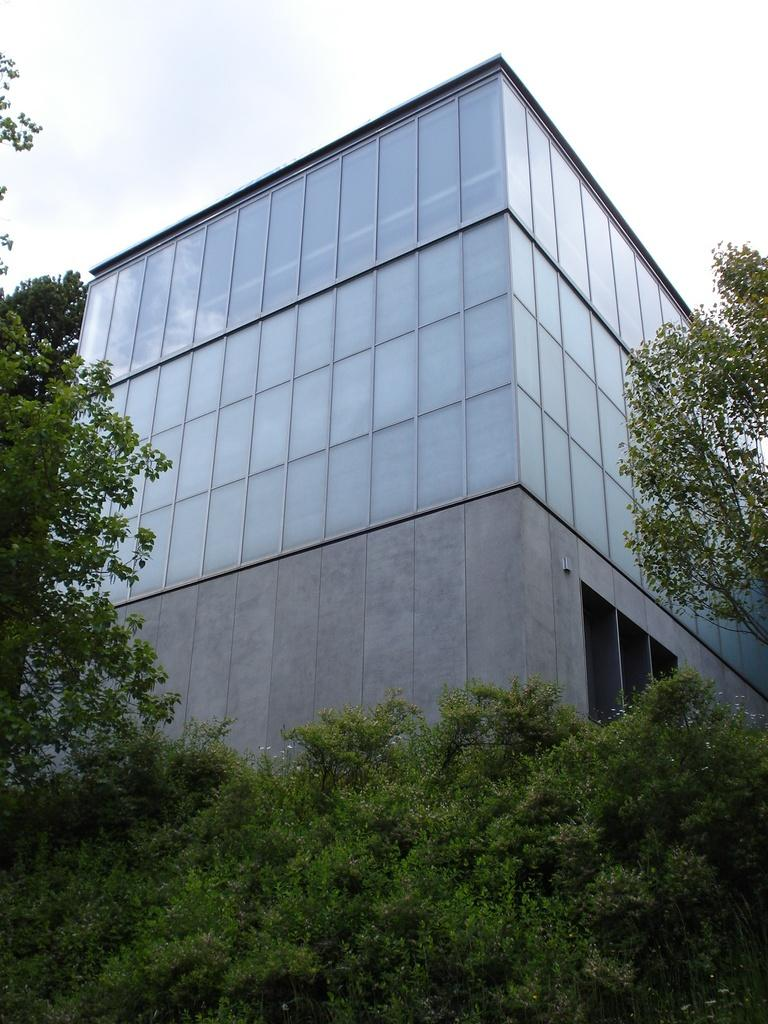What type of structure is present in the image? There is a building in the image. What feature can be observed on the building? The building has glass panels. What type of vegetation is visible in the image? There are trees in the image. What is visible in the background of the image? The sky is visible in the image. How many flowers can be seen in the image? There are no flowers present in the image. Are there any bikes visible in the scene? There is no mention of bikes in the provided facts, so we cannot determine if they are present in the image. 